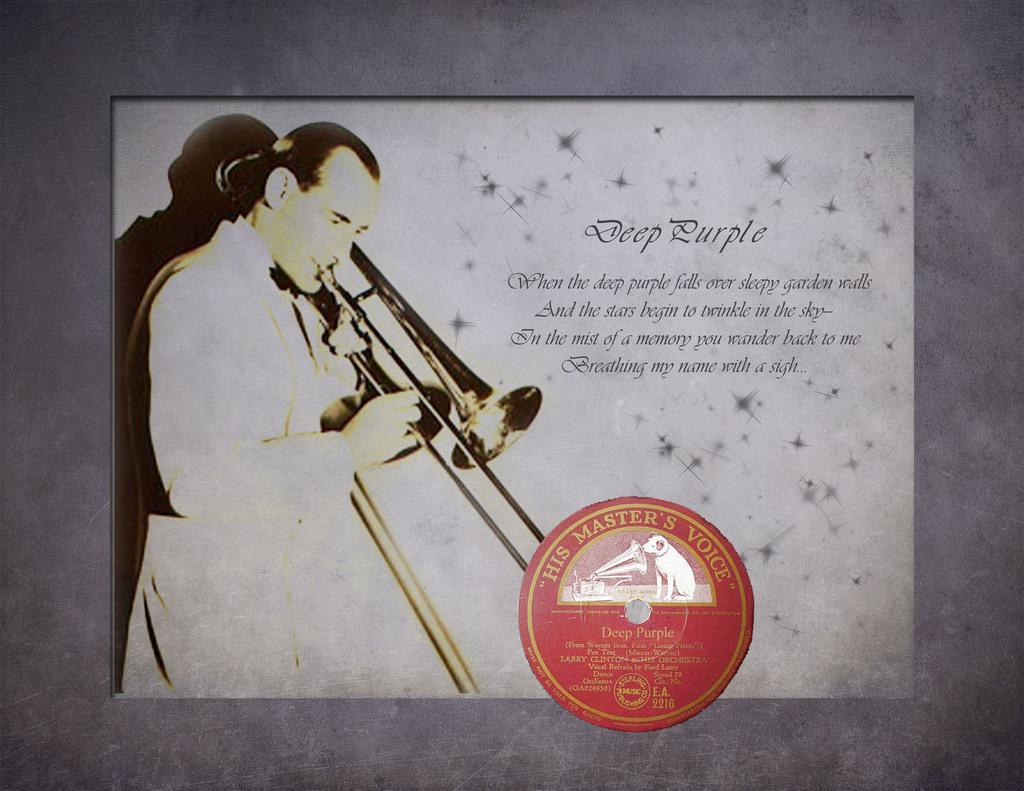What is present on the poster in the image? The poster contains text and images. What can be seen in the background of the image? There is a wall in the background of the image. What type of sponge is being used to clean the lawyer's detail on the poster? There is no sponge, lawyer, or detail present in the image. 